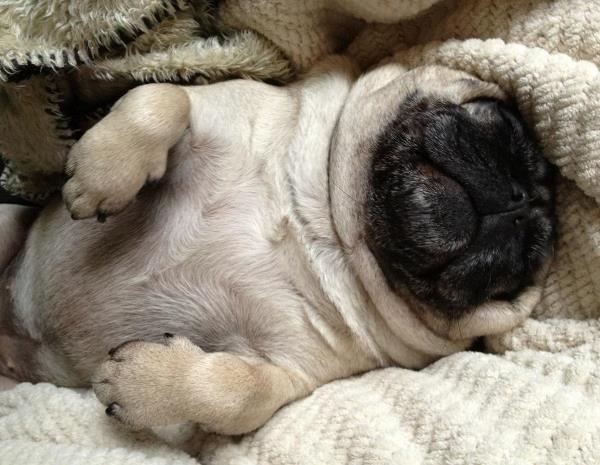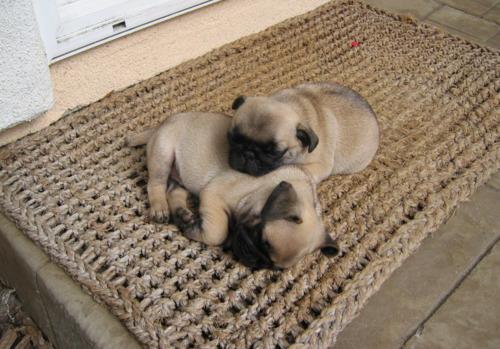The first image is the image on the left, the second image is the image on the right. For the images displayed, is the sentence "One white dog and one brown dog are sleeping." factually correct? Answer yes or no. No. 